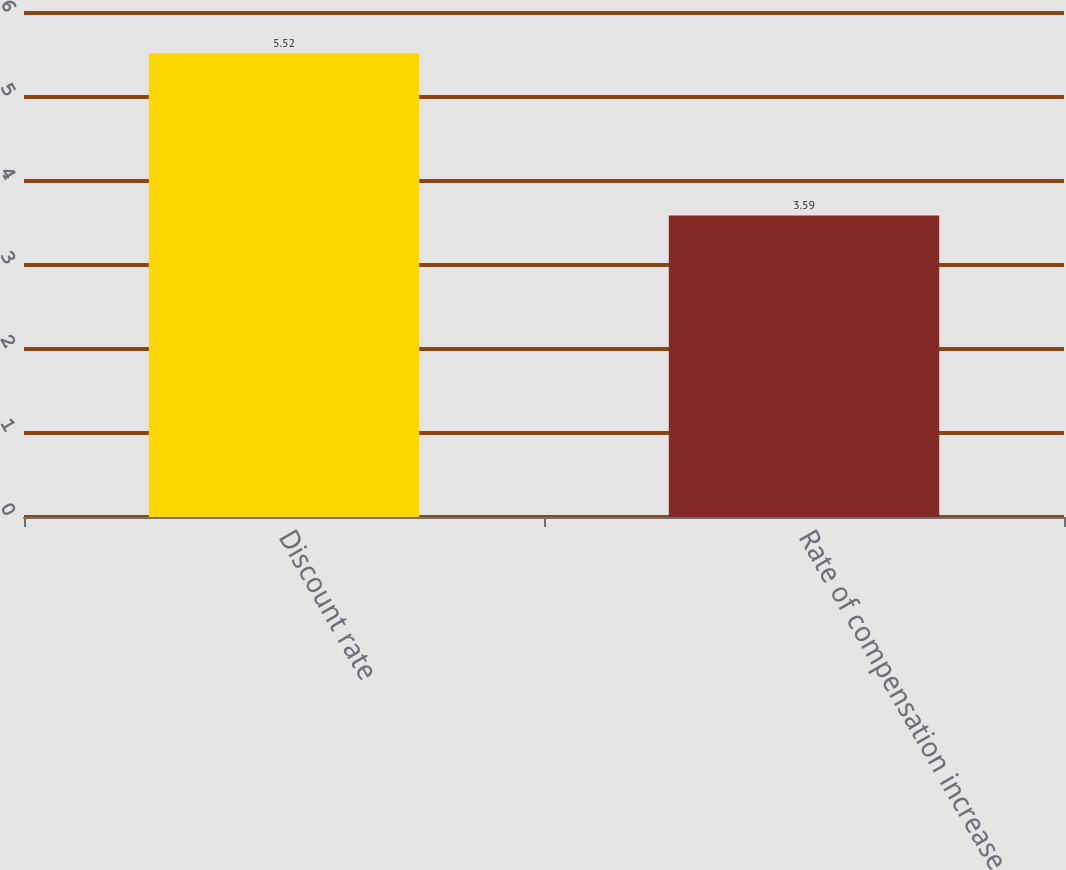<chart> <loc_0><loc_0><loc_500><loc_500><bar_chart><fcel>Discount rate<fcel>Rate of compensation increase<nl><fcel>5.52<fcel>3.59<nl></chart> 